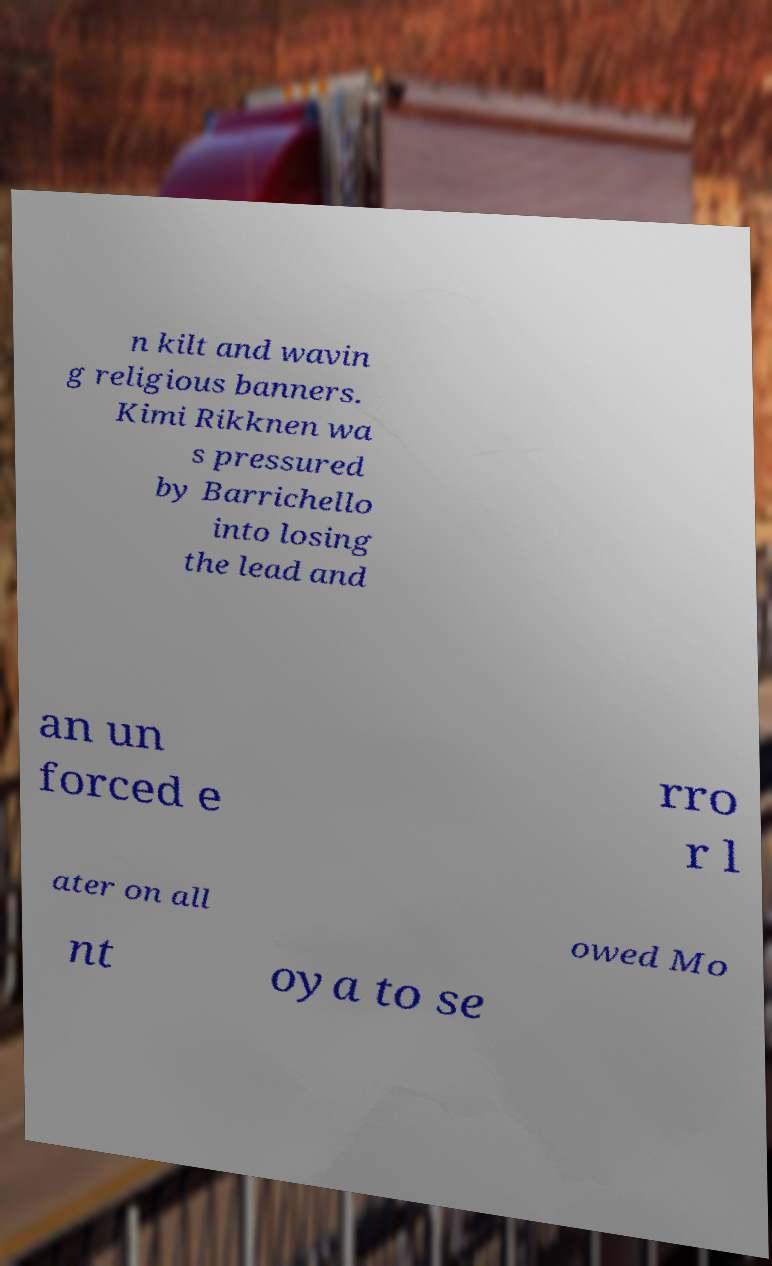Could you assist in decoding the text presented in this image and type it out clearly? n kilt and wavin g religious banners. Kimi Rikknen wa s pressured by Barrichello into losing the lead and an un forced e rro r l ater on all owed Mo nt oya to se 